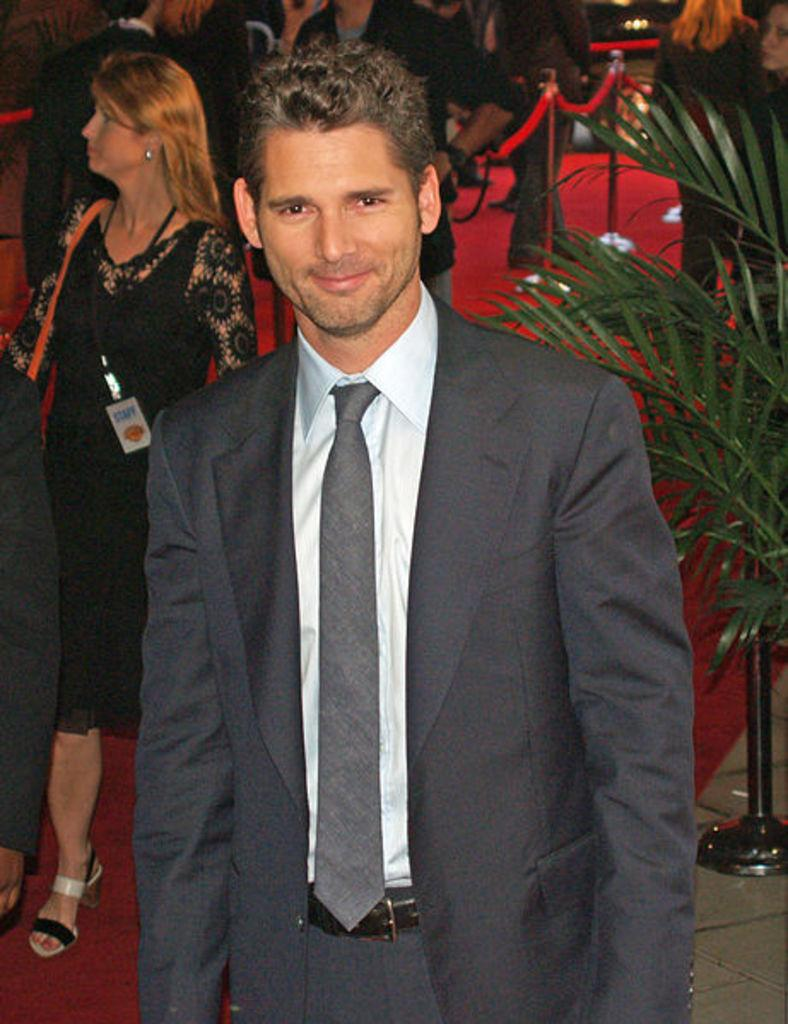How many people are in the image? There are people in the image, but the exact number is not specified. What is the man in the image doing? The man is standing and smiling in the image. What is the man wearing? The man is wearing a suit in the image. What type of plant can be seen in the image? There is a plant in the image, but its specific type is not mentioned. What is the color of the carpet in the image? There is a red carpet in the image. What type of apparatus is the rat using to communicate with the man in the image? There is no rat or apparatus present in the image. What letters are the people in the image holding? There is no mention of letters or people holding anything in the image. 